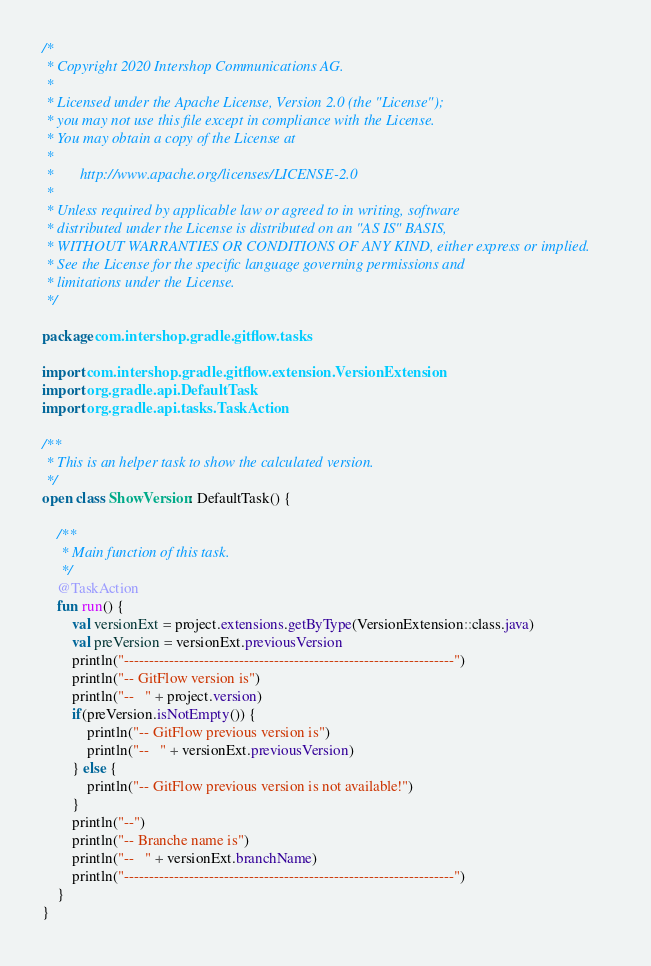<code> <loc_0><loc_0><loc_500><loc_500><_Kotlin_>/*
 * Copyright 2020 Intershop Communications AG.
 *
 * Licensed under the Apache License, Version 2.0 (the "License");
 * you may not use this file except in compliance with the License.
 * You may obtain a copy of the License at
 *
 *       http://www.apache.org/licenses/LICENSE-2.0
 *
 * Unless required by applicable law or agreed to in writing, software
 * distributed under the License is distributed on an "AS IS" BASIS,
 * WITHOUT WARRANTIES OR CONDITIONS OF ANY KIND, either express or implied.
 * See the License for the specific language governing permissions and
 * limitations under the License.
 */

package com.intershop.gradle.gitflow.tasks

import com.intershop.gradle.gitflow.extension.VersionExtension
import org.gradle.api.DefaultTask
import org.gradle.api.tasks.TaskAction

/**
 * This is an helper task to show the calculated version.
 */
open class ShowVersion: DefaultTask() {

    /**
     * Main function of this task.
     */
    @TaskAction
    fun run() {
        val versionExt = project.extensions.getByType(VersionExtension::class.java)
        val preVersion = versionExt.previousVersion
        println("------------------------------------------------------------------")
        println("-- GitFlow version is")
        println("--   " + project.version)
        if(preVersion.isNotEmpty()) {
            println("-- GitFlow previous version is")
            println("--   " + versionExt.previousVersion)
        } else {
            println("-- GitFlow previous version is not available!")
        }
        println("--")
        println("-- Branche name is")
        println("--   " + versionExt.branchName)
        println("------------------------------------------------------------------")
    }
}
</code> 